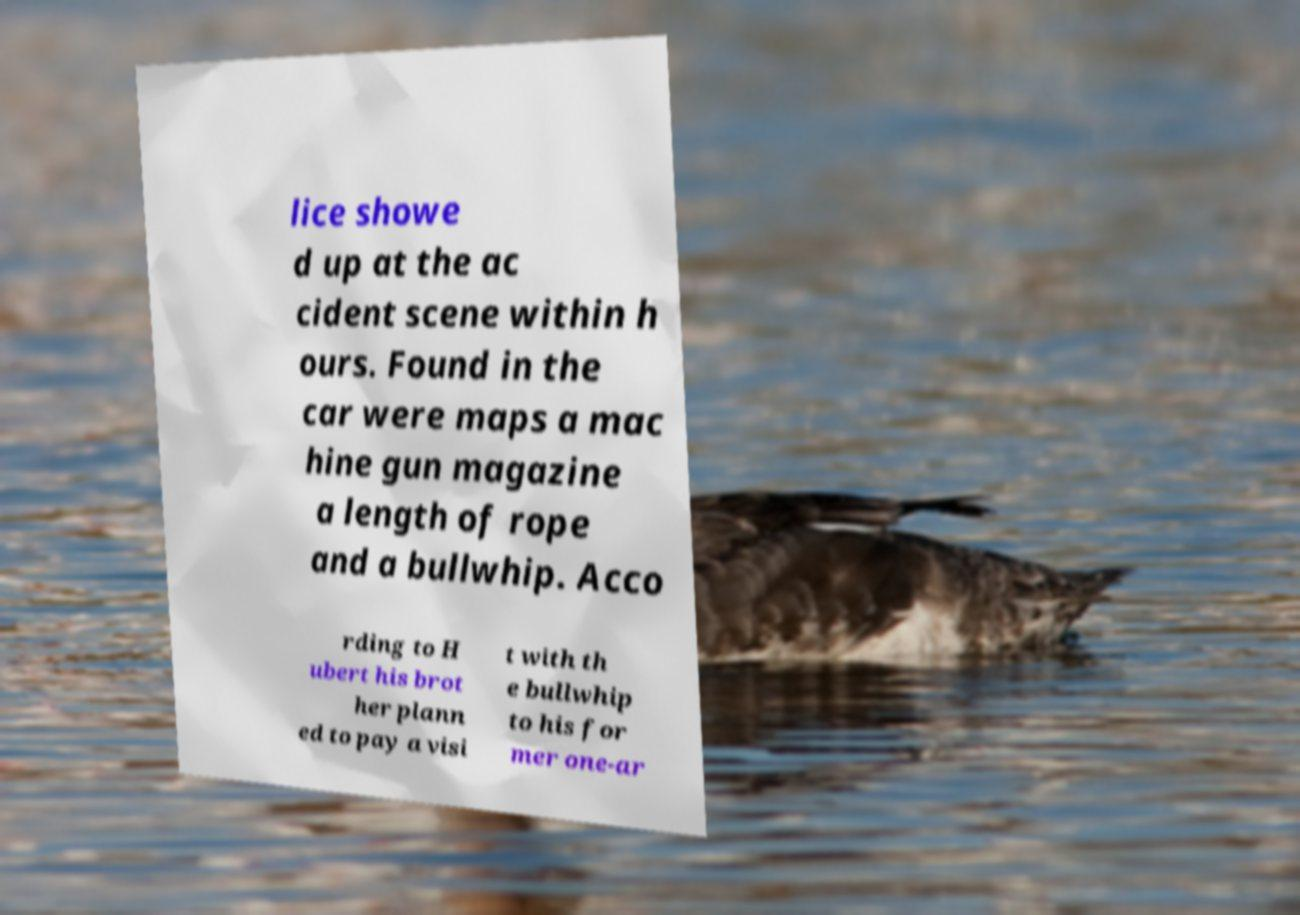Can you accurately transcribe the text from the provided image for me? lice showe d up at the ac cident scene within h ours. Found in the car were maps a mac hine gun magazine a length of rope and a bullwhip. Acco rding to H ubert his brot her plann ed to pay a visi t with th e bullwhip to his for mer one-ar 